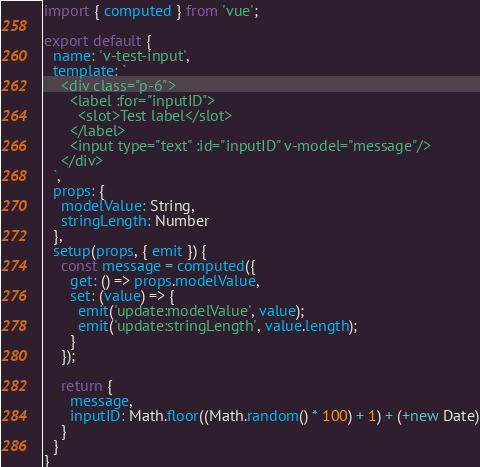Convert code to text. <code><loc_0><loc_0><loc_500><loc_500><_JavaScript_>import { computed } from 'vue';

export default {
  name: 'v-test-input',
  template: `
    <div class="p-6">
      <label :for="inputID">
        <slot>Test label</slot>
      </label>
      <input type="text" :id="inputID" v-model="message"/>
    </div>
  `,
  props: {
    modelValue: String,
    stringLength: Number
  },
  setup(props, { emit }) {
    const message = computed({
      get: () => props.modelValue,
      set: (value) => {
        emit('update:modelValue', value);
        emit('update:stringLength', value.length);
      }
    });

    return {
      message,
      inputID: Math.floor((Math.random() * 100) + 1) + (+new Date)
    }
  }
}
</code> 